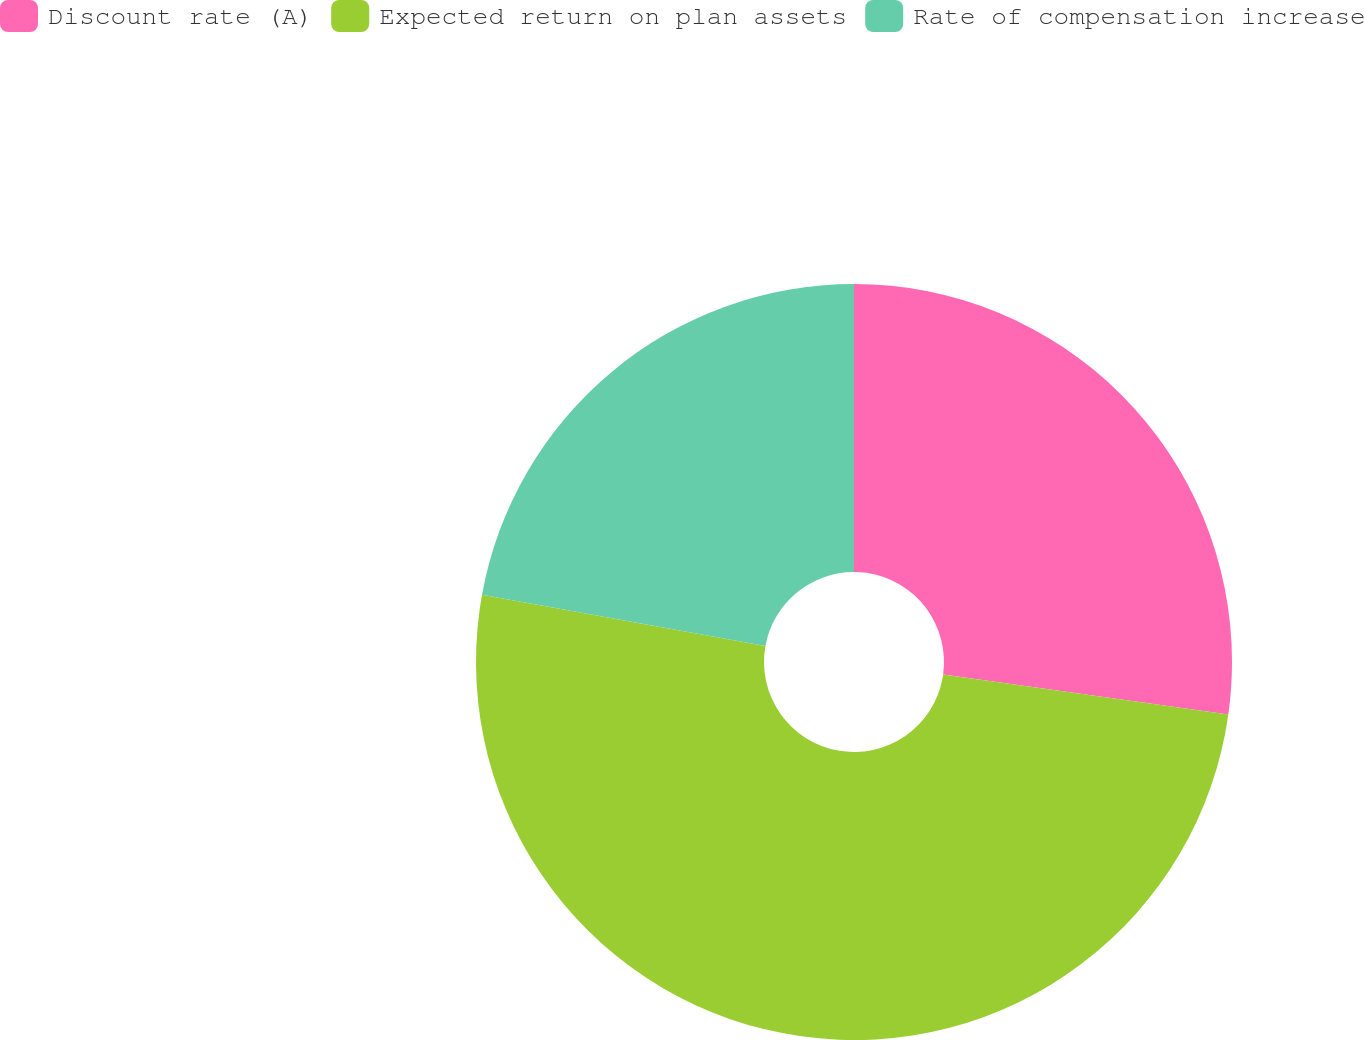Convert chart. <chart><loc_0><loc_0><loc_500><loc_500><pie_chart><fcel>Discount rate (A)<fcel>Expected return on plan assets<fcel>Rate of compensation increase<nl><fcel>27.22%<fcel>50.63%<fcel>22.15%<nl></chart> 